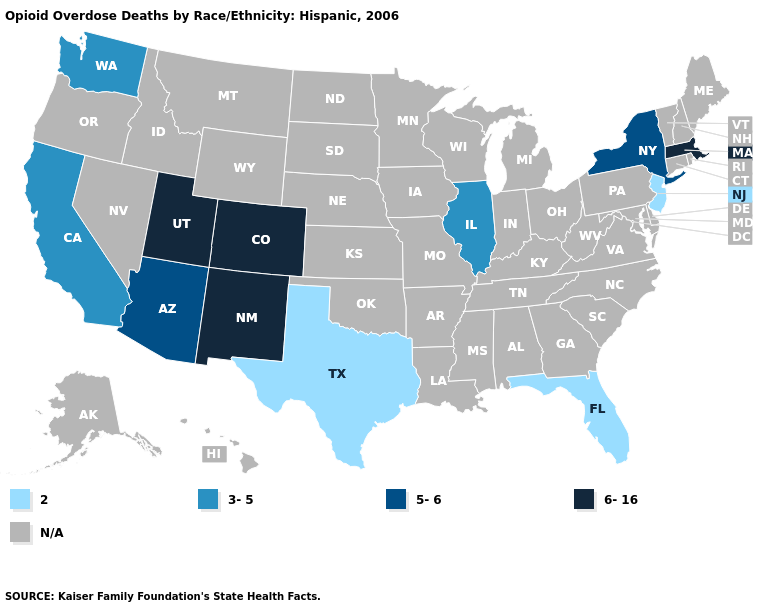What is the lowest value in states that border Arizona?
Give a very brief answer. 3-5. Which states hav the highest value in the Northeast?
Short answer required. Massachusetts. Is the legend a continuous bar?
Concise answer only. No. What is the value of Florida?
Write a very short answer. 2. Name the states that have a value in the range N/A?
Keep it brief. Alabama, Alaska, Arkansas, Connecticut, Delaware, Georgia, Hawaii, Idaho, Indiana, Iowa, Kansas, Kentucky, Louisiana, Maine, Maryland, Michigan, Minnesota, Mississippi, Missouri, Montana, Nebraska, Nevada, New Hampshire, North Carolina, North Dakota, Ohio, Oklahoma, Oregon, Pennsylvania, Rhode Island, South Carolina, South Dakota, Tennessee, Vermont, Virginia, West Virginia, Wisconsin, Wyoming. Name the states that have a value in the range 6-16?
Concise answer only. Colorado, Massachusetts, New Mexico, Utah. What is the value of California?
Be succinct. 3-5. What is the highest value in the USA?
Give a very brief answer. 6-16. What is the highest value in the USA?
Give a very brief answer. 6-16. What is the highest value in states that border Nevada?
Quick response, please. 6-16. Name the states that have a value in the range 5-6?
Keep it brief. Arizona, New York. What is the value of Kansas?
Quick response, please. N/A. Which states hav the highest value in the MidWest?
Quick response, please. Illinois. Which states have the lowest value in the USA?
Quick response, please. Florida, New Jersey, Texas. Name the states that have a value in the range 3-5?
Give a very brief answer. California, Illinois, Washington. 